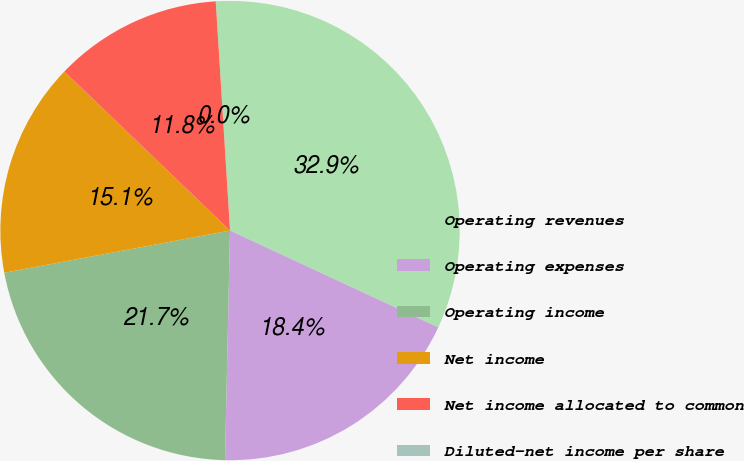Convert chart to OTSL. <chart><loc_0><loc_0><loc_500><loc_500><pie_chart><fcel>Operating revenues<fcel>Operating expenses<fcel>Operating income<fcel>Net income<fcel>Net income allocated to common<fcel>Diluted-net income per share<nl><fcel>32.92%<fcel>18.42%<fcel>21.71%<fcel>15.12%<fcel>11.83%<fcel>0.0%<nl></chart> 